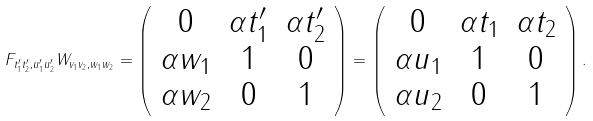<formula> <loc_0><loc_0><loc_500><loc_500>F _ { t _ { 1 } ^ { \prime } t _ { 2 } ^ { \prime } , u _ { 1 } ^ { \prime } u _ { 2 } ^ { \prime } } W _ { v _ { 1 } v _ { 2 } , w _ { 1 } w _ { 2 } } = \left ( \begin{array} { c c c } 0 & \alpha t _ { 1 } ^ { \prime } & \alpha t _ { 2 } ^ { \prime } \\ \alpha w _ { 1 } & 1 & 0 \\ \alpha w _ { 2 } & 0 & 1 \end{array} \right ) = \left ( \begin{array} { c c c } 0 & \alpha t _ { 1 } & \alpha t _ { 2 } \\ \alpha u _ { 1 } & 1 & 0 \\ \alpha u _ { 2 } & 0 & 1 \end{array} \right ) .</formula> 